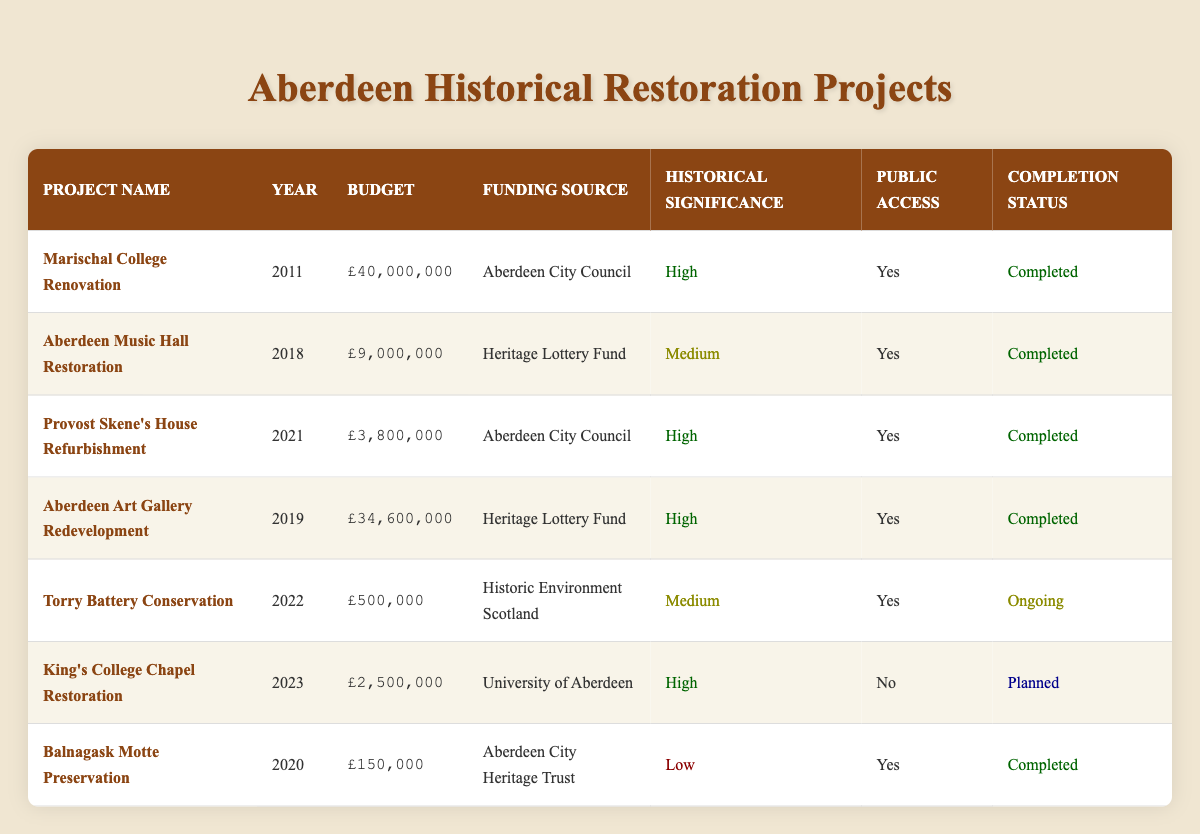What is the budget for the Aberdeen Music Hall Restoration? The budget for the Aberdeen Music Hall Restoration project is listed in the table under the "Budget" column, which shows £9,000,000 for that specific project.
Answer: £9,000,000 How many restoration projects have public access? To find the number of projects with public access, we look at the "Public Access" column for each project and count the entries marked "Yes." In total, there are five projects with public access: Marischal College Renovation, Aberdeen Music Hall Restoration, Provost Skene's House Refurbishment, Aberdeen Art Gallery Redevelopment, and Balnagask Motte Preservation.
Answer: 5 What is the total budget for all completed restoration projects? We add the budgets of all projects that have the completion status "Completed." The budgets are: £40,000,000 (Marischal College), £9,000,000 (Aberdeen Music Hall), £3,800,000 (Provost Skene's House), £34,600,000 (Aberdeen Art Gallery), and £150,000 (Balnagask Motte). Adding these together gives us a total of £87,600,000.
Answer: £87,600,000 Is the King's College Chapel Restoration open to the public? The table specifies the "Public Access" column for the King's College Chapel Restoration, which is marked as "No," indicating it does not have public access.
Answer: No What is the average budget of the historical restoration projects that have high historical significance? First, identify the projects with high historical significance, which are Marischal College Renovation, Provost Skene's House Refurbishment, Aberdeen Art Gallery Redevelopment, and King's College Chapel Restoration. Their budgets are £40,000,000, £3,800,000, £34,600,000, and £2,500,000 respectively. We calculate the average by summing these budgets: £40,000,000 + £3,800,000 + £34,600,000 + £2,500,000 = £81,900,000. There are four projects, so we divide this total by four to get the average: £81,900,000 / 4 = £20,475,000.
Answer: £20,475,000 How many projects are ongoing or planned? We need to look for projects listed as "Ongoing" or "Planned" in the "Completion Status" column. The ongoing project is Torry Battery Conservation, and the planned project is King's College Chapel Restoration. Therefore, there are a total of two projects that are either ongoing or planned.
Answer: 2 What was the year of completion for the Torry Battery Conservation project? The table lists the completion status for the Torry Battery Conservation as "Ongoing," which implies it has not been completed yet and therefore does not have a completion year.
Answer: N/A Which project had the highest budget and what was that budget? We analyze the "Budget" column to identify the project with the highest amount. The Marischal College Renovation's budget of £40,000,000 is the highest compared to the others in the table.
Answer: £40,000,000 